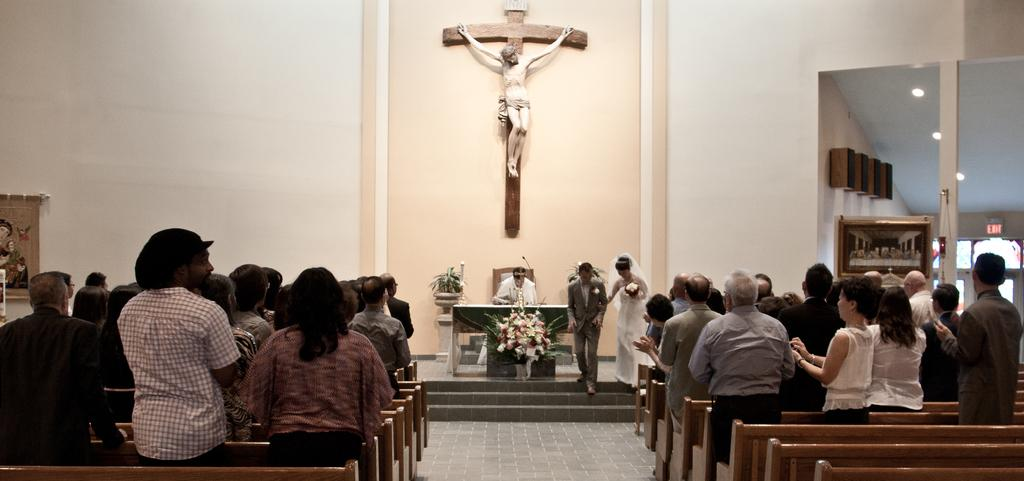What event is taking place in the image? There are people attending a ceremony in the image. What type of ceremony is it? The ceremony is for a newly wed couple. What can be seen in the background of the image? There is a wall in the background of the image. Is there any religious symbolism in the image? Yes, there is a statue of Jesus Christ attached to the wall in the background. How does the fog affect the reaction of the guests during the ceremony? There is no fog present in the image, so it cannot affect the guests' reactions. 